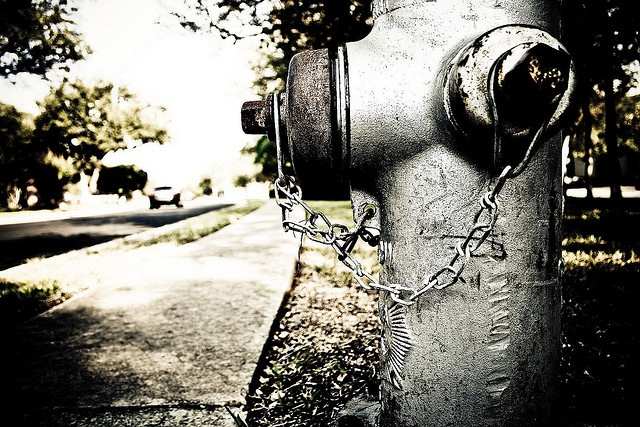Describe the objects in this image and their specific colors. I can see fire hydrant in black, white, darkgray, and gray tones and car in black, white, gray, and darkgray tones in this image. 